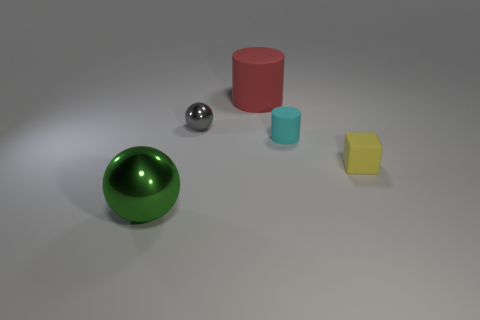Subtract all brown cylinders. Subtract all gray balls. How many cylinders are left? 2 Add 1 big red shiny cylinders. How many objects exist? 6 Subtract all balls. How many objects are left? 3 Subtract all small matte objects. Subtract all shiny balls. How many objects are left? 1 Add 3 yellow cubes. How many yellow cubes are left? 4 Add 2 red rubber cylinders. How many red rubber cylinders exist? 3 Subtract 0 yellow cylinders. How many objects are left? 5 